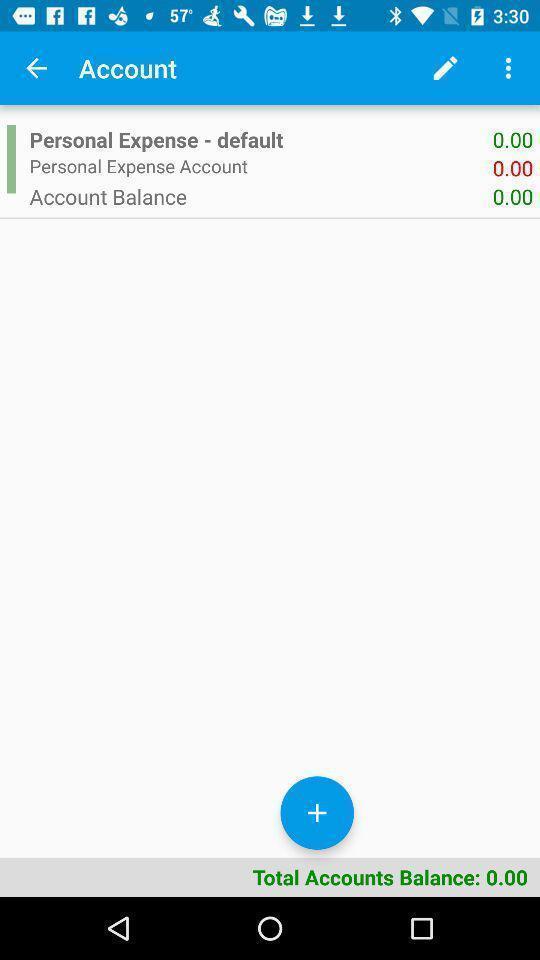Provide a description of this screenshot. Showing account balance in the financial app. 